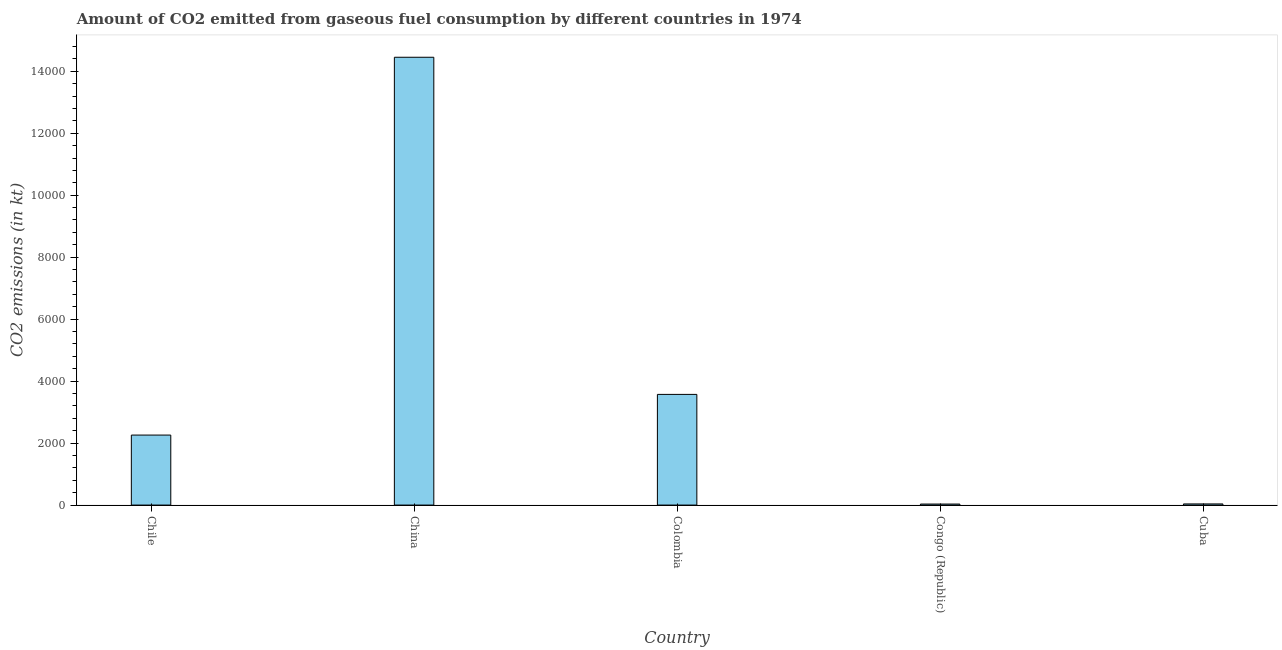Does the graph contain any zero values?
Provide a succinct answer. No. Does the graph contain grids?
Offer a terse response. No. What is the title of the graph?
Provide a succinct answer. Amount of CO2 emitted from gaseous fuel consumption by different countries in 1974. What is the label or title of the X-axis?
Provide a succinct answer. Country. What is the label or title of the Y-axis?
Ensure brevity in your answer.  CO2 emissions (in kt). What is the co2 emissions from gaseous fuel consumption in Colombia?
Provide a short and direct response. 3571.66. Across all countries, what is the maximum co2 emissions from gaseous fuel consumption?
Make the answer very short. 1.45e+04. Across all countries, what is the minimum co2 emissions from gaseous fuel consumption?
Provide a short and direct response. 33. In which country was the co2 emissions from gaseous fuel consumption maximum?
Your answer should be very brief. China. In which country was the co2 emissions from gaseous fuel consumption minimum?
Keep it short and to the point. Congo (Republic). What is the sum of the co2 emissions from gaseous fuel consumption?
Offer a very short reply. 2.04e+04. What is the difference between the co2 emissions from gaseous fuel consumption in Colombia and Cuba?
Offer a very short reply. 3534.99. What is the average co2 emissions from gaseous fuel consumption per country?
Ensure brevity in your answer.  4070.37. What is the median co2 emissions from gaseous fuel consumption?
Keep it short and to the point. 2258.87. In how many countries, is the co2 emissions from gaseous fuel consumption greater than 2800 kt?
Make the answer very short. 2. What is the ratio of the co2 emissions from gaseous fuel consumption in Colombia to that in Congo (Republic)?
Give a very brief answer. 108.22. Is the co2 emissions from gaseous fuel consumption in Chile less than that in Congo (Republic)?
Offer a very short reply. No. What is the difference between the highest and the second highest co2 emissions from gaseous fuel consumption?
Ensure brevity in your answer.  1.09e+04. Is the sum of the co2 emissions from gaseous fuel consumption in China and Cuba greater than the maximum co2 emissions from gaseous fuel consumption across all countries?
Ensure brevity in your answer.  Yes. What is the difference between the highest and the lowest co2 emissions from gaseous fuel consumption?
Your answer should be compact. 1.44e+04. How many bars are there?
Provide a succinct answer. 5. Are the values on the major ticks of Y-axis written in scientific E-notation?
Provide a succinct answer. No. What is the CO2 emissions (in kt) of Chile?
Your response must be concise. 2258.87. What is the CO2 emissions (in kt) of China?
Ensure brevity in your answer.  1.45e+04. What is the CO2 emissions (in kt) in Colombia?
Your answer should be very brief. 3571.66. What is the CO2 emissions (in kt) of Congo (Republic)?
Give a very brief answer. 33. What is the CO2 emissions (in kt) of Cuba?
Keep it short and to the point. 36.67. What is the difference between the CO2 emissions (in kt) in Chile and China?
Provide a succinct answer. -1.22e+04. What is the difference between the CO2 emissions (in kt) in Chile and Colombia?
Offer a very short reply. -1312.79. What is the difference between the CO2 emissions (in kt) in Chile and Congo (Republic)?
Make the answer very short. 2225.87. What is the difference between the CO2 emissions (in kt) in Chile and Cuba?
Provide a succinct answer. 2222.2. What is the difference between the CO2 emissions (in kt) in China and Colombia?
Make the answer very short. 1.09e+04. What is the difference between the CO2 emissions (in kt) in China and Congo (Republic)?
Offer a very short reply. 1.44e+04. What is the difference between the CO2 emissions (in kt) in China and Cuba?
Give a very brief answer. 1.44e+04. What is the difference between the CO2 emissions (in kt) in Colombia and Congo (Republic)?
Your response must be concise. 3538.66. What is the difference between the CO2 emissions (in kt) in Colombia and Cuba?
Offer a terse response. 3534.99. What is the difference between the CO2 emissions (in kt) in Congo (Republic) and Cuba?
Provide a short and direct response. -3.67. What is the ratio of the CO2 emissions (in kt) in Chile to that in China?
Give a very brief answer. 0.16. What is the ratio of the CO2 emissions (in kt) in Chile to that in Colombia?
Your answer should be very brief. 0.63. What is the ratio of the CO2 emissions (in kt) in Chile to that in Congo (Republic)?
Give a very brief answer. 68.44. What is the ratio of the CO2 emissions (in kt) in Chile to that in Cuba?
Your response must be concise. 61.6. What is the ratio of the CO2 emissions (in kt) in China to that in Colombia?
Provide a succinct answer. 4.05. What is the ratio of the CO2 emissions (in kt) in China to that in Congo (Republic)?
Your answer should be very brief. 437.89. What is the ratio of the CO2 emissions (in kt) in China to that in Cuba?
Your response must be concise. 394.1. What is the ratio of the CO2 emissions (in kt) in Colombia to that in Congo (Republic)?
Provide a succinct answer. 108.22. What is the ratio of the CO2 emissions (in kt) in Colombia to that in Cuba?
Offer a very short reply. 97.4. 